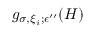Convert formula to latex. <formula><loc_0><loc_0><loc_500><loc_500>g _ { \sigma , \xi _ { i } ; \epsilon ^ { \prime \prime } } ( H )</formula> 